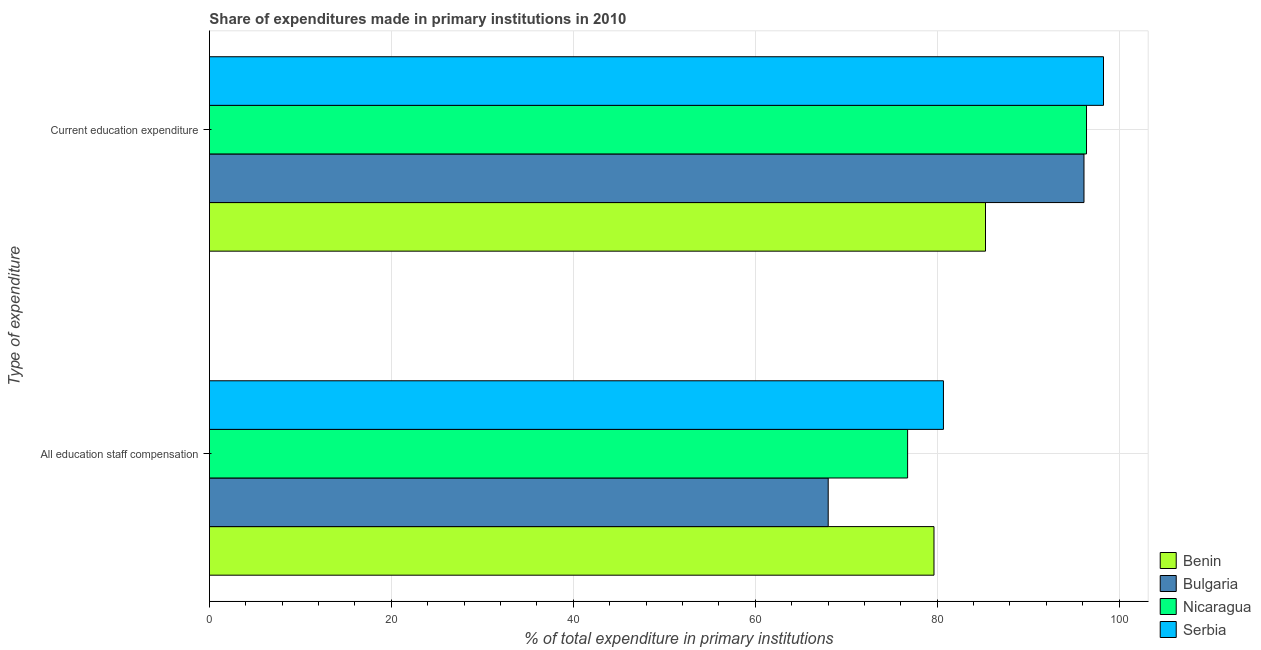Are the number of bars on each tick of the Y-axis equal?
Give a very brief answer. Yes. How many bars are there on the 2nd tick from the bottom?
Give a very brief answer. 4. What is the label of the 1st group of bars from the top?
Keep it short and to the point. Current education expenditure. What is the expenditure in education in Serbia?
Your response must be concise. 98.28. Across all countries, what is the maximum expenditure in education?
Provide a succinct answer. 98.28. Across all countries, what is the minimum expenditure in education?
Your answer should be compact. 85.31. In which country was the expenditure in staff compensation maximum?
Provide a succinct answer. Serbia. What is the total expenditure in staff compensation in the graph?
Keep it short and to the point. 305.1. What is the difference between the expenditure in education in Nicaragua and that in Bulgaria?
Offer a very short reply. 0.28. What is the difference between the expenditure in education in Bulgaria and the expenditure in staff compensation in Nicaragua?
Ensure brevity in your answer.  19.39. What is the average expenditure in education per country?
Offer a very short reply. 94.04. What is the difference between the expenditure in staff compensation and expenditure in education in Benin?
Offer a very short reply. -5.66. In how many countries, is the expenditure in staff compensation greater than 64 %?
Your answer should be compact. 4. What is the ratio of the expenditure in education in Benin to that in Serbia?
Provide a short and direct response. 0.87. What does the 3rd bar from the top in Current education expenditure represents?
Keep it short and to the point. Bulgaria. What does the 3rd bar from the bottom in All education staff compensation represents?
Give a very brief answer. Nicaragua. Are the values on the major ticks of X-axis written in scientific E-notation?
Provide a succinct answer. No. Does the graph contain grids?
Give a very brief answer. Yes. How are the legend labels stacked?
Your answer should be very brief. Vertical. What is the title of the graph?
Your answer should be compact. Share of expenditures made in primary institutions in 2010. Does "Poland" appear as one of the legend labels in the graph?
Your answer should be compact. No. What is the label or title of the X-axis?
Make the answer very short. % of total expenditure in primary institutions. What is the label or title of the Y-axis?
Your answer should be very brief. Type of expenditure. What is the % of total expenditure in primary institutions in Benin in All education staff compensation?
Give a very brief answer. 79.65. What is the % of total expenditure in primary institutions in Bulgaria in All education staff compensation?
Your answer should be very brief. 68.02. What is the % of total expenditure in primary institutions in Nicaragua in All education staff compensation?
Provide a short and direct response. 76.75. What is the % of total expenditure in primary institutions of Serbia in All education staff compensation?
Your response must be concise. 80.69. What is the % of total expenditure in primary institutions in Benin in Current education expenditure?
Offer a terse response. 85.31. What is the % of total expenditure in primary institutions of Bulgaria in Current education expenditure?
Provide a short and direct response. 96.14. What is the % of total expenditure in primary institutions of Nicaragua in Current education expenditure?
Give a very brief answer. 96.41. What is the % of total expenditure in primary institutions of Serbia in Current education expenditure?
Your response must be concise. 98.28. Across all Type of expenditure, what is the maximum % of total expenditure in primary institutions of Benin?
Make the answer very short. 85.31. Across all Type of expenditure, what is the maximum % of total expenditure in primary institutions in Bulgaria?
Provide a succinct answer. 96.14. Across all Type of expenditure, what is the maximum % of total expenditure in primary institutions in Nicaragua?
Ensure brevity in your answer.  96.41. Across all Type of expenditure, what is the maximum % of total expenditure in primary institutions of Serbia?
Your answer should be compact. 98.28. Across all Type of expenditure, what is the minimum % of total expenditure in primary institutions of Benin?
Offer a very short reply. 79.65. Across all Type of expenditure, what is the minimum % of total expenditure in primary institutions in Bulgaria?
Provide a short and direct response. 68.02. Across all Type of expenditure, what is the minimum % of total expenditure in primary institutions of Nicaragua?
Provide a succinct answer. 76.75. Across all Type of expenditure, what is the minimum % of total expenditure in primary institutions of Serbia?
Provide a succinct answer. 80.69. What is the total % of total expenditure in primary institutions in Benin in the graph?
Offer a terse response. 164.96. What is the total % of total expenditure in primary institutions in Bulgaria in the graph?
Offer a terse response. 164.15. What is the total % of total expenditure in primary institutions in Nicaragua in the graph?
Give a very brief answer. 173.16. What is the total % of total expenditure in primary institutions in Serbia in the graph?
Your answer should be very brief. 178.97. What is the difference between the % of total expenditure in primary institutions of Benin in All education staff compensation and that in Current education expenditure?
Make the answer very short. -5.66. What is the difference between the % of total expenditure in primary institutions in Bulgaria in All education staff compensation and that in Current education expenditure?
Provide a succinct answer. -28.12. What is the difference between the % of total expenditure in primary institutions of Nicaragua in All education staff compensation and that in Current education expenditure?
Make the answer very short. -19.67. What is the difference between the % of total expenditure in primary institutions of Serbia in All education staff compensation and that in Current education expenditure?
Your response must be concise. -17.6. What is the difference between the % of total expenditure in primary institutions in Benin in All education staff compensation and the % of total expenditure in primary institutions in Bulgaria in Current education expenditure?
Provide a short and direct response. -16.49. What is the difference between the % of total expenditure in primary institutions of Benin in All education staff compensation and the % of total expenditure in primary institutions of Nicaragua in Current education expenditure?
Ensure brevity in your answer.  -16.77. What is the difference between the % of total expenditure in primary institutions in Benin in All education staff compensation and the % of total expenditure in primary institutions in Serbia in Current education expenditure?
Provide a succinct answer. -18.63. What is the difference between the % of total expenditure in primary institutions of Bulgaria in All education staff compensation and the % of total expenditure in primary institutions of Nicaragua in Current education expenditure?
Provide a short and direct response. -28.39. What is the difference between the % of total expenditure in primary institutions of Bulgaria in All education staff compensation and the % of total expenditure in primary institutions of Serbia in Current education expenditure?
Offer a terse response. -30.26. What is the difference between the % of total expenditure in primary institutions of Nicaragua in All education staff compensation and the % of total expenditure in primary institutions of Serbia in Current education expenditure?
Keep it short and to the point. -21.53. What is the average % of total expenditure in primary institutions of Benin per Type of expenditure?
Ensure brevity in your answer.  82.48. What is the average % of total expenditure in primary institutions of Bulgaria per Type of expenditure?
Your answer should be very brief. 82.08. What is the average % of total expenditure in primary institutions in Nicaragua per Type of expenditure?
Give a very brief answer. 86.58. What is the average % of total expenditure in primary institutions in Serbia per Type of expenditure?
Give a very brief answer. 89.48. What is the difference between the % of total expenditure in primary institutions in Benin and % of total expenditure in primary institutions in Bulgaria in All education staff compensation?
Offer a terse response. 11.63. What is the difference between the % of total expenditure in primary institutions of Benin and % of total expenditure in primary institutions of Nicaragua in All education staff compensation?
Keep it short and to the point. 2.9. What is the difference between the % of total expenditure in primary institutions of Benin and % of total expenditure in primary institutions of Serbia in All education staff compensation?
Make the answer very short. -1.04. What is the difference between the % of total expenditure in primary institutions of Bulgaria and % of total expenditure in primary institutions of Nicaragua in All education staff compensation?
Offer a very short reply. -8.73. What is the difference between the % of total expenditure in primary institutions in Bulgaria and % of total expenditure in primary institutions in Serbia in All education staff compensation?
Make the answer very short. -12.67. What is the difference between the % of total expenditure in primary institutions in Nicaragua and % of total expenditure in primary institutions in Serbia in All education staff compensation?
Keep it short and to the point. -3.94. What is the difference between the % of total expenditure in primary institutions of Benin and % of total expenditure in primary institutions of Bulgaria in Current education expenditure?
Your answer should be very brief. -10.83. What is the difference between the % of total expenditure in primary institutions in Benin and % of total expenditure in primary institutions in Nicaragua in Current education expenditure?
Offer a terse response. -11.1. What is the difference between the % of total expenditure in primary institutions in Benin and % of total expenditure in primary institutions in Serbia in Current education expenditure?
Make the answer very short. -12.97. What is the difference between the % of total expenditure in primary institutions in Bulgaria and % of total expenditure in primary institutions in Nicaragua in Current education expenditure?
Make the answer very short. -0.28. What is the difference between the % of total expenditure in primary institutions of Bulgaria and % of total expenditure in primary institutions of Serbia in Current education expenditure?
Make the answer very short. -2.15. What is the difference between the % of total expenditure in primary institutions in Nicaragua and % of total expenditure in primary institutions in Serbia in Current education expenditure?
Provide a short and direct response. -1.87. What is the ratio of the % of total expenditure in primary institutions of Benin in All education staff compensation to that in Current education expenditure?
Your response must be concise. 0.93. What is the ratio of the % of total expenditure in primary institutions of Bulgaria in All education staff compensation to that in Current education expenditure?
Keep it short and to the point. 0.71. What is the ratio of the % of total expenditure in primary institutions in Nicaragua in All education staff compensation to that in Current education expenditure?
Your answer should be very brief. 0.8. What is the ratio of the % of total expenditure in primary institutions in Serbia in All education staff compensation to that in Current education expenditure?
Offer a terse response. 0.82. What is the difference between the highest and the second highest % of total expenditure in primary institutions of Benin?
Make the answer very short. 5.66. What is the difference between the highest and the second highest % of total expenditure in primary institutions of Bulgaria?
Provide a succinct answer. 28.12. What is the difference between the highest and the second highest % of total expenditure in primary institutions in Nicaragua?
Provide a short and direct response. 19.67. What is the difference between the highest and the second highest % of total expenditure in primary institutions in Serbia?
Keep it short and to the point. 17.6. What is the difference between the highest and the lowest % of total expenditure in primary institutions in Benin?
Your answer should be compact. 5.66. What is the difference between the highest and the lowest % of total expenditure in primary institutions in Bulgaria?
Make the answer very short. 28.12. What is the difference between the highest and the lowest % of total expenditure in primary institutions in Nicaragua?
Make the answer very short. 19.67. What is the difference between the highest and the lowest % of total expenditure in primary institutions of Serbia?
Your answer should be compact. 17.6. 